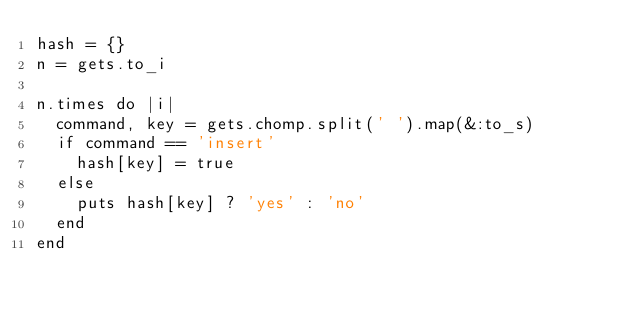<code> <loc_0><loc_0><loc_500><loc_500><_Ruby_>hash = {}
n = gets.to_i

n.times do |i|
  command, key = gets.chomp.split(' ').map(&:to_s)
  if command == 'insert'
    hash[key] = true
  else
    puts hash[key] ? 'yes' : 'no'
  end
end</code> 